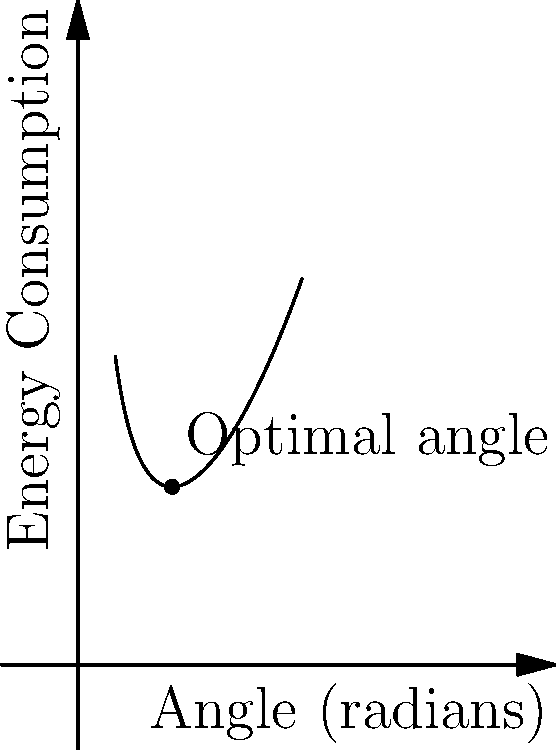In our paper folding mechanism, the energy consumption $E$ (in joules) as a function of the folding angle $\theta$ (in radians) is given by the equation:

$$E(\theta) = 0.5\theta^2 + \frac{2}{\theta}$$

What is the optimal angle $\theta$ that minimizes energy consumption, and what is the corresponding minimum energy value? To find the optimal angle that minimizes energy consumption, we need to follow these steps:

1) First, we need to find the derivative of the energy function:
   $$\frac{dE}{d\theta} = \theta - \frac{2}{\theta^2}$$

2) To find the minimum, we set the derivative equal to zero:
   $$\theta - \frac{2}{\theta^2} = 0$$

3) Multiply both sides by $\theta^2$:
   $$\theta^3 - 2 = 0$$

4) Solve for $\theta$:
   $$\theta^3 = 2$$
   $$\theta = \sqrt[3]{2} \approx 1.26$$

5) To confirm this is a minimum, we can check the second derivative is positive:
   $$\frac{d^2E}{d\theta^2} = 1 + \frac{4}{\theta^3} > 0$$

6) Calculate the minimum energy by plugging the optimal angle back into the original equation:
   $$E(\sqrt[3]{2}) = 0.5(\sqrt[3]{2})^2 + \frac{2}{\sqrt[3]{2}} = 0.5 \cdot 2^{2/3} + 2 \cdot 2^{-1/3} = 3 \cdot 2^{-1/3} \approx 2.38$$

Therefore, the optimal angle is $\sqrt[3]{2}$ radians, and the minimum energy consumption is $3 \cdot 2^{-1/3}$ joules.
Answer: $\theta = \sqrt[3]{2} \approx 1.26$ radians, $E_{min} = 3 \cdot 2^{-1/3} \approx 2.38$ joules 